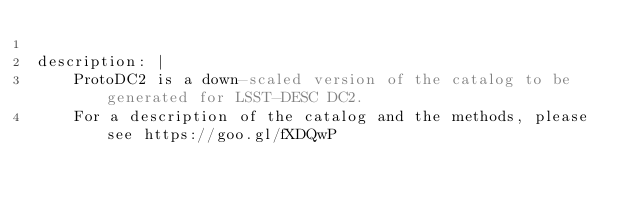Convert code to text. <code><loc_0><loc_0><loc_500><loc_500><_YAML_>
description: |
    ProtoDC2 is a down-scaled version of the catalog to be generated for LSST-DESC DC2.
    For a description of the catalog and the methods, please see https://goo.gl/fXDQwP
</code> 